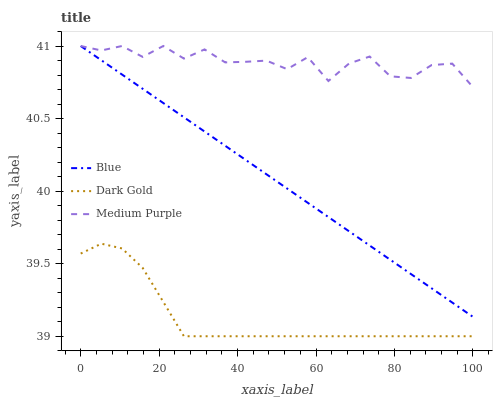Does Medium Purple have the minimum area under the curve?
Answer yes or no. No. Does Dark Gold have the maximum area under the curve?
Answer yes or no. No. Is Dark Gold the smoothest?
Answer yes or no. No. Is Dark Gold the roughest?
Answer yes or no. No. Does Medium Purple have the lowest value?
Answer yes or no. No. Does Dark Gold have the highest value?
Answer yes or no. No. Is Dark Gold less than Medium Purple?
Answer yes or no. Yes. Is Blue greater than Dark Gold?
Answer yes or no. Yes. Does Dark Gold intersect Medium Purple?
Answer yes or no. No. 